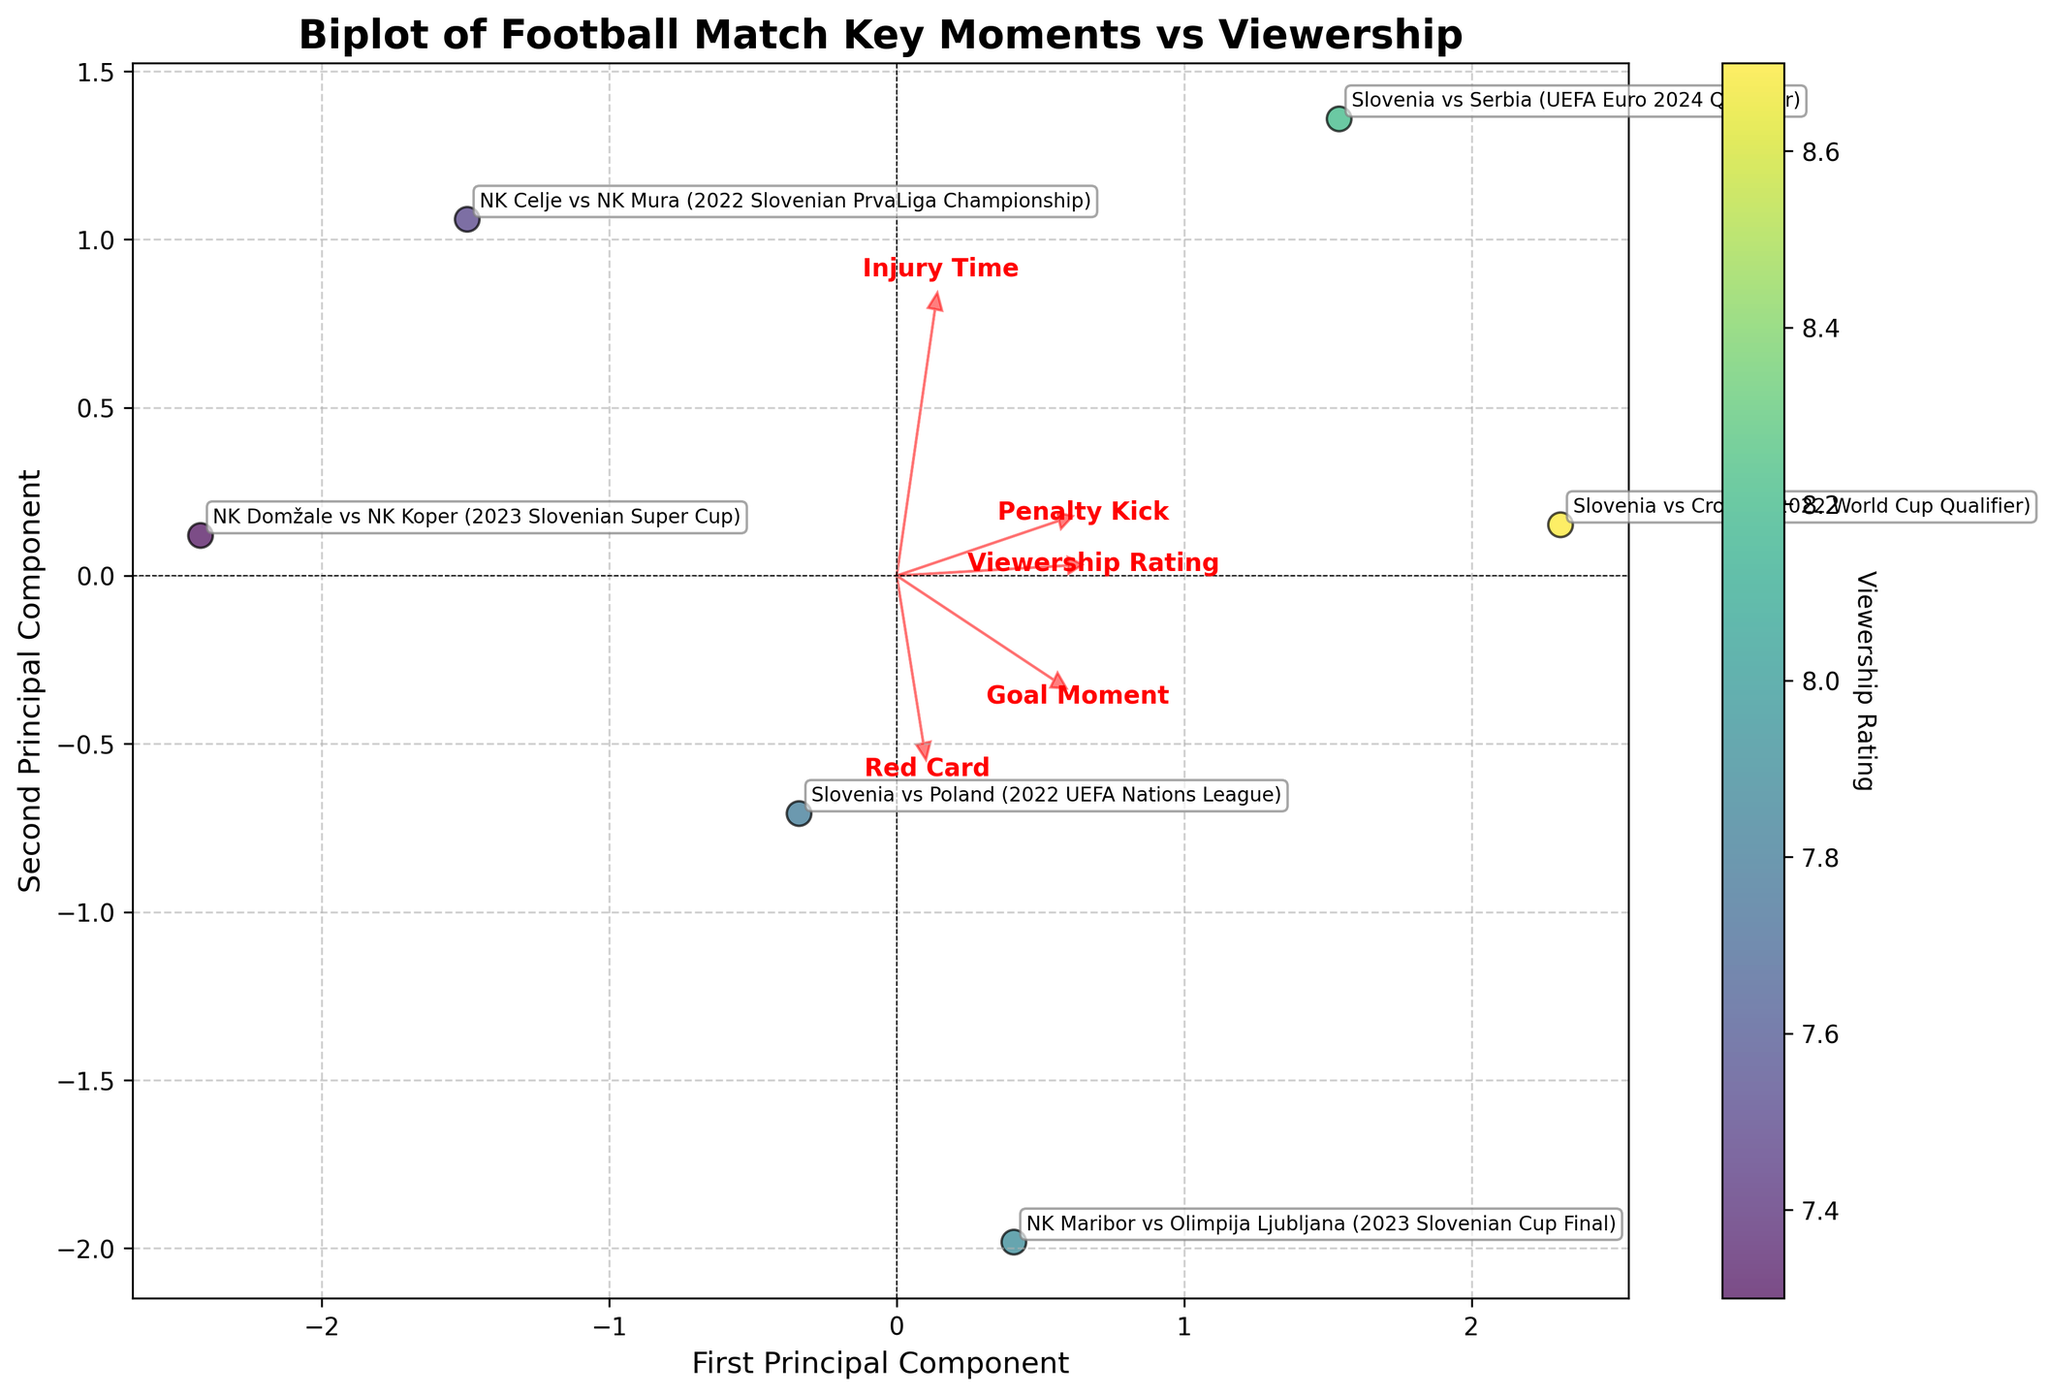What is the title of the plot? The title of the plot is displayed at the top and is "Biplot of Football Match Key Moments vs Viewership".
Answer: Biplot of Football Match Key Moments vs Viewership How many data points are represented in the plot? Each data point represents one football event. Observing the scatter plot, there are 6 labeled data points (one for each event).
Answer: 6 Which event had the highest viewership rating? By examining the color gradient (viridis color map) and annotations, the event "Slovenia vs Croatia (2022 World Cup Qualifier)" appears the darkest, indicating the highest rating.
Answer: Slovenia vs Croatia (2022 World Cup Qualifier) What does the first principal component represent on the x-axis? The x-axis is labeled "First Principal Component" which represents the primary direction with the most variance in the data. The feature vectors (arrows) indicate the contributions of different key moments to this principal component.
Answer: The primary direction with the most variance Which key moment has the largest positive contribution to the first principal component? Observing the arrows, "Goal Moment" has the longest arrow pointing mostly along the x-axis for the first principal component.
Answer: Goal Moment How do "Goal Moment" and "Viewership Rating" relate to each other? The arrow for "Goal Moment" points toward higher values of the first principal component, where data points with higher viewership ratings are also located. This suggests a positive relationship between "Goal Moment" and "Viewership Rating".
Answer: Positive relationship Which event is closest to the origin (0,0) in the biplot? By examining the scatter plot, the event "NK Domžale vs NK Koper (2023 Slovenian Super Cup)" is closest to the origin.
Answer: NK Domžale vs NK Koper (2023 Slovenian Super Cup) Does "Red Card" contribute more to the first or the second principal component? The arrow for "Red Card" points more vertically than horizontally, indicating it contributes more to the second principal component (y-axis) than the first (x-axis).
Answer: Second principal component Which key moment has the smallest overall contribution to both principal components? By comparing the lengths of the arrows, "Injury Time" has the shortest vector, indicating the smallest contribution to both principal components.
Answer: Injury Time 